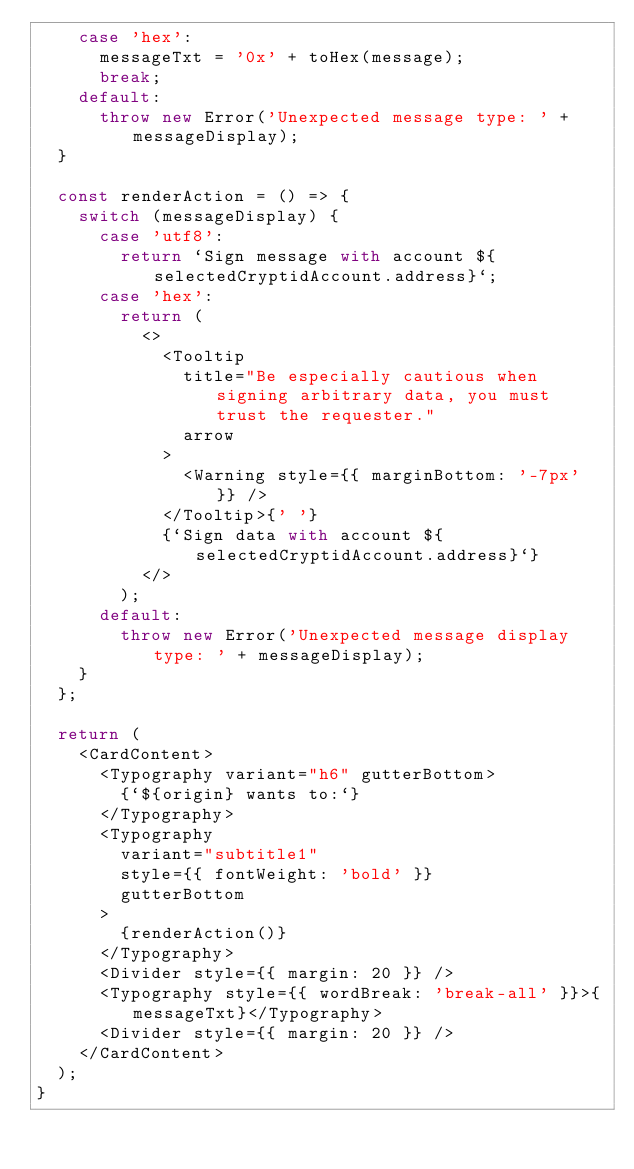Convert code to text. <code><loc_0><loc_0><loc_500><loc_500><_JavaScript_>    case 'hex':
      messageTxt = '0x' + toHex(message);
      break;
    default:
      throw new Error('Unexpected message type: ' + messageDisplay);
  }

  const renderAction = () => {
    switch (messageDisplay) {
      case 'utf8':
        return `Sign message with account ${selectedCryptidAccount.address}`;
      case 'hex':
        return (
          <>
            <Tooltip
              title="Be especially cautious when signing arbitrary data, you must trust the requester."
              arrow
            >
              <Warning style={{ marginBottom: '-7px' }} />
            </Tooltip>{' '}
            {`Sign data with account ${selectedCryptidAccount.address}`}
          </>
        );
      default:
        throw new Error('Unexpected message display type: ' + messageDisplay);
    }
  };

  return (
    <CardContent>
      <Typography variant="h6" gutterBottom>
        {`${origin} wants to:`}
      </Typography>
      <Typography
        variant="subtitle1"
        style={{ fontWeight: 'bold' }}
        gutterBottom
      >
        {renderAction()}
      </Typography>
      <Divider style={{ margin: 20 }} />
      <Typography style={{ wordBreak: 'break-all' }}>{messageTxt}</Typography>
      <Divider style={{ margin: 20 }} />
    </CardContent>
  );
}
</code> 